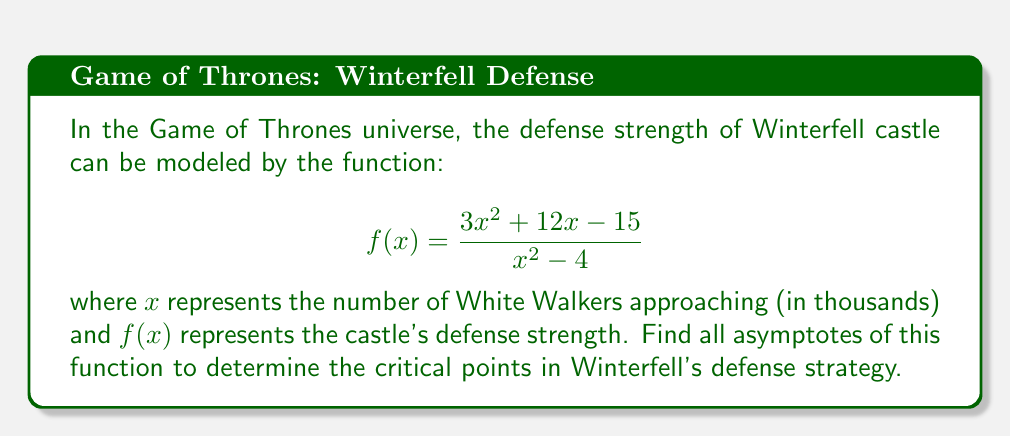Show me your answer to this math problem. To find the asymptotes, we need to analyze the function step by step:

1. Vertical asymptotes:
   Set the denominator to zero and solve for x:
   $$x^2 - 4 = 0$$
   $$(x+2)(x-2) = 0$$
   $$x = -2 \text{ or } x = 2$$

2. Horizontal asymptote:
   Compare the degrees of the numerator and denominator:
   Numerator degree: 2
   Denominator degree: 2
   Since they are equal, divide the leading coefficients:
   $$\lim_{x \to \infty} \frac{3x^2}{x^2} = 3$$

3. Slant asymptote:
   Since the degree of the numerator is equal to the degree of the denominator, there is no slant asymptote.

4. To find the y-intercept (if it exists), set x = 0:
   $$f(0) = \frac{3(0)^2 + 12(0) - 15}{(0)^2 - 4} = \frac{-15}{-4} = \frac{15}{4}$$

Therefore, we have:
- Vertical asymptotes: $x = -2$ and $x = 2$
- Horizontal asymptote: $y = 3$
- Y-intercept: $(0, \frac{15}{4})$
Answer: Vertical asymptotes: $x = -2, x = 2$; Horizontal asymptote: $y = 3$ 